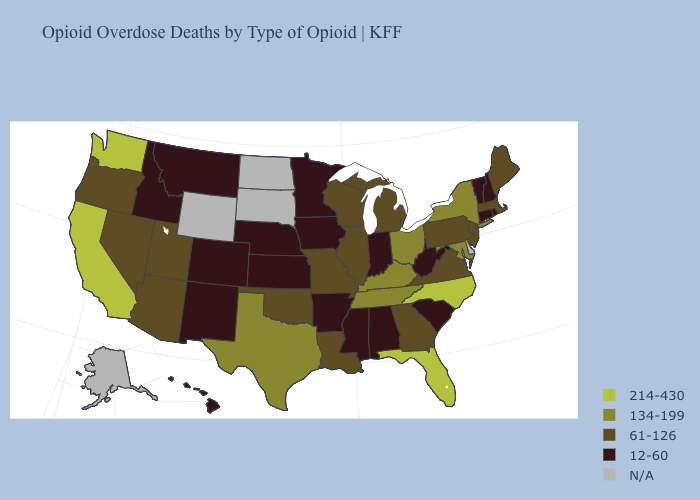Among the states that border Missouri , which have the highest value?
Quick response, please. Kentucky, Tennessee. What is the value of West Virginia?
Write a very short answer. 12-60. Does North Carolina have the lowest value in the South?
Be succinct. No. What is the value of Alaska?
Be succinct. N/A. Which states hav the highest value in the South?
Answer briefly. Florida, North Carolina. Name the states that have a value in the range 61-126?
Keep it brief. Arizona, Georgia, Illinois, Louisiana, Maine, Massachusetts, Michigan, Missouri, Nevada, New Jersey, Oklahoma, Oregon, Pennsylvania, Utah, Virginia, Wisconsin. What is the value of Hawaii?
Be succinct. 12-60. Among the states that border California , which have the lowest value?
Keep it brief. Arizona, Nevada, Oregon. Does the first symbol in the legend represent the smallest category?
Be succinct. No. Which states have the lowest value in the USA?
Keep it brief. Alabama, Arkansas, Colorado, Connecticut, Hawaii, Idaho, Indiana, Iowa, Kansas, Minnesota, Mississippi, Montana, Nebraska, New Hampshire, New Mexico, Rhode Island, South Carolina, Vermont, West Virginia. Does Washington have the highest value in the USA?
Short answer required. Yes. What is the highest value in the USA?
Answer briefly. 214-430. What is the value of South Carolina?
Keep it brief. 12-60. Which states have the lowest value in the USA?
Answer briefly. Alabama, Arkansas, Colorado, Connecticut, Hawaii, Idaho, Indiana, Iowa, Kansas, Minnesota, Mississippi, Montana, Nebraska, New Hampshire, New Mexico, Rhode Island, South Carolina, Vermont, West Virginia. 